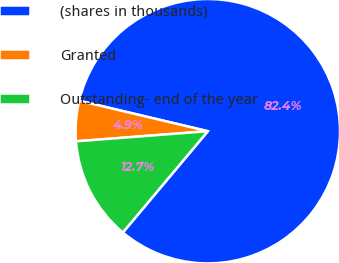<chart> <loc_0><loc_0><loc_500><loc_500><pie_chart><fcel>(shares in thousands)<fcel>Granted<fcel>Outstanding- end of the year<nl><fcel>82.41%<fcel>4.92%<fcel>12.67%<nl></chart> 